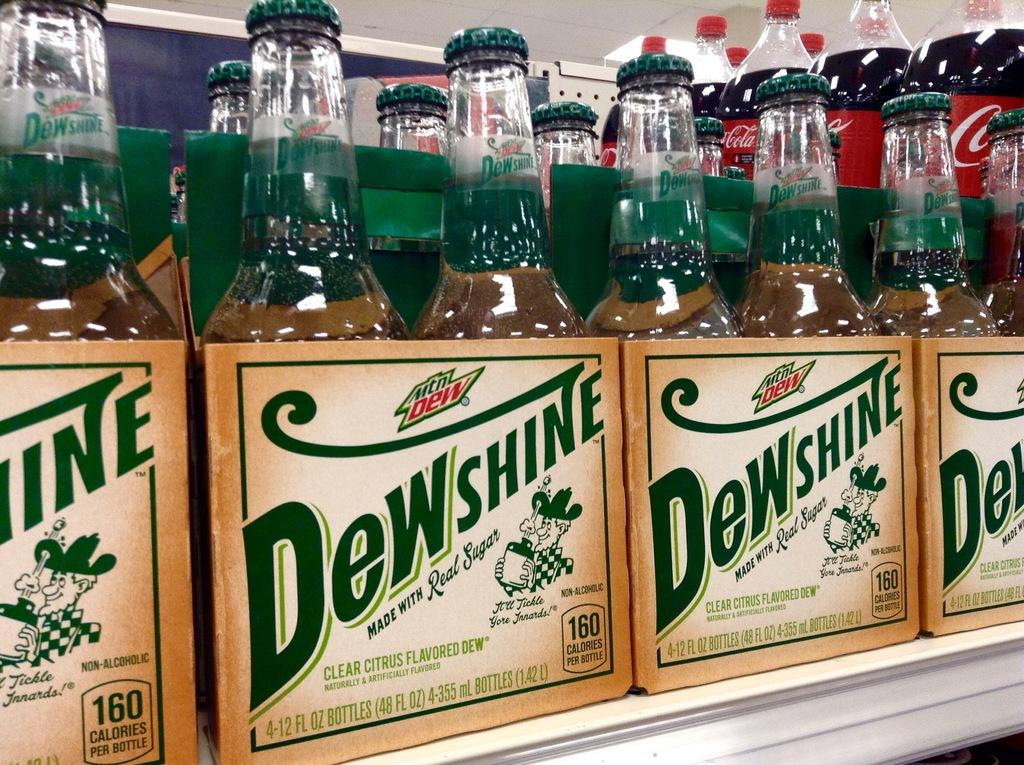<image>
Relay a brief, clear account of the picture shown. shelf with 4 packs of mountain dew dewshine, made with real sugar 